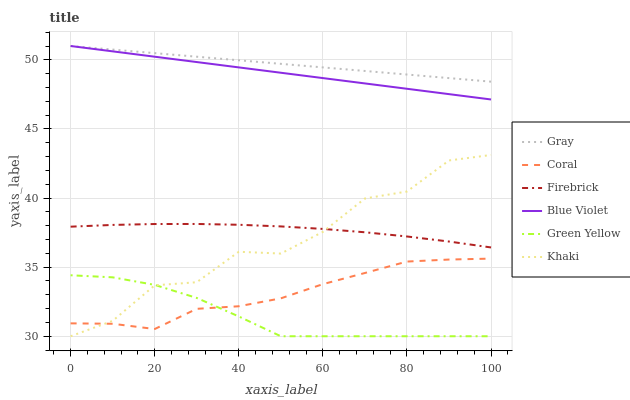Does Khaki have the minimum area under the curve?
Answer yes or no. No. Does Khaki have the maximum area under the curve?
Answer yes or no. No. Is Coral the smoothest?
Answer yes or no. No. Is Coral the roughest?
Answer yes or no. No. Does Coral have the lowest value?
Answer yes or no. No. Does Khaki have the highest value?
Answer yes or no. No. Is Khaki less than Gray?
Answer yes or no. Yes. Is Gray greater than Firebrick?
Answer yes or no. Yes. Does Khaki intersect Gray?
Answer yes or no. No. 